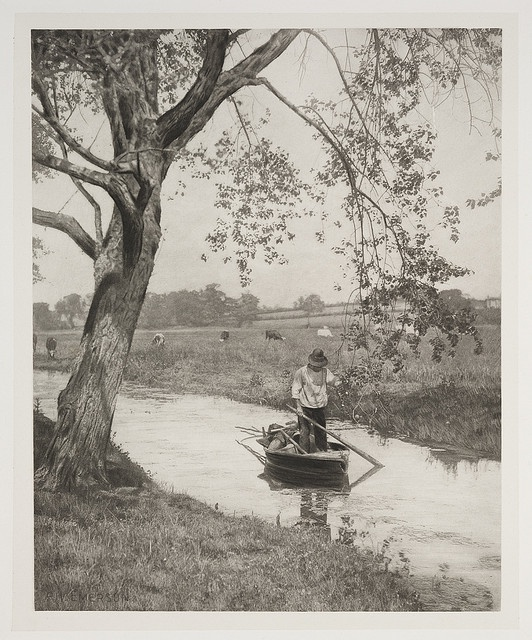Describe the objects in this image and their specific colors. I can see boat in lightgray, black, gray, and darkgray tones, people in lightgray, gray, darkgray, and black tones, cow in lightgray, gray, darkgray, and black tones, cow in lightgray, gray, and darkgray tones, and cow in lightgray and darkgray tones in this image. 